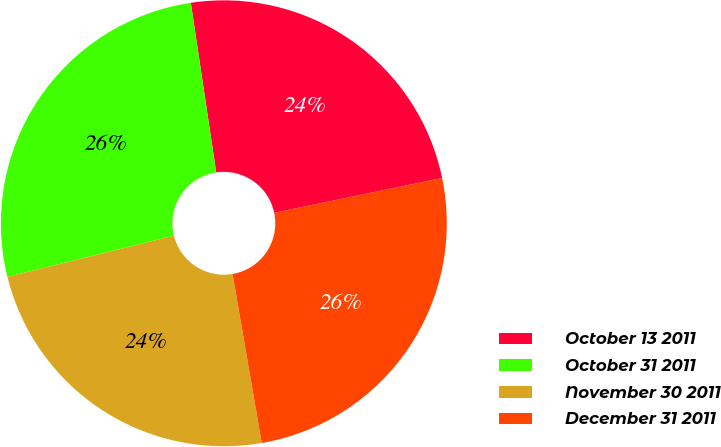<chart> <loc_0><loc_0><loc_500><loc_500><pie_chart><fcel>October 13 2011<fcel>October 31 2011<fcel>November 30 2011<fcel>December 31 2011<nl><fcel>24.11%<fcel>26.5%<fcel>23.85%<fcel>25.54%<nl></chart> 